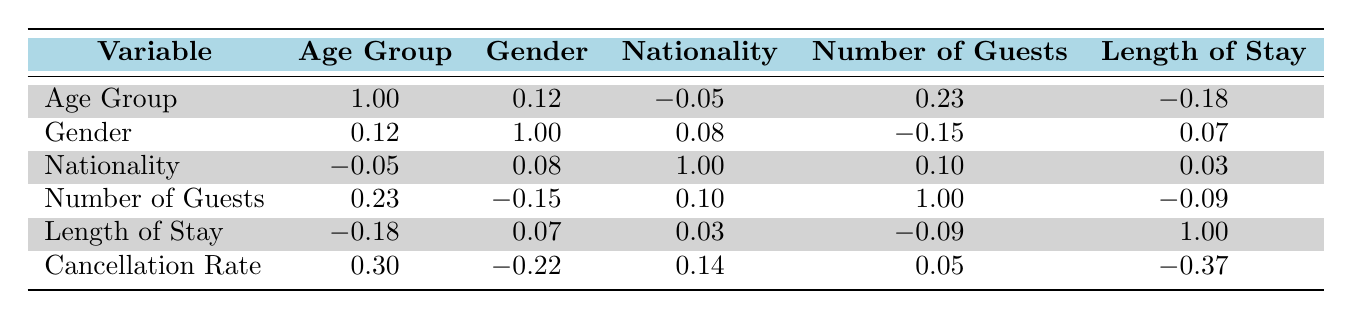What is the cancellation rate for female guests in the age group 55+? The table shows that for female guests in the age group 55+, the cancellation rate is listed as 0.20.
Answer: 0.20 How many guests are in the age group 25-34? There are two entries under the age group 25-34, one for a male guest with 1 guest and another for a female guest with 2 guests. By summing these values, 1 + 2 = 3 guests total.
Answer: 3 What is the correlation between the number of guests and the cancellation rate? Looking at the correlation table, the correlation coefficient between the number of guests and the cancellation rate is 0.05, which indicates a very weak positive correlation.
Answer: 0.05 Is the cancellation rate higher for female guests than for male guests? To answer this question, I compare the cancellation rates for each gender. Female guests have rates of 0.15 (age 18-24), 0.05 (age 35-44), and 0.20 (age 55+), giving an average of (0.15 + 0.05 + 0.20)/3 = 0.133. Male guests have rates of 0.08 (age 25-34), 0.12 (age 45-54), and 0.10 (age 18-24), giving (0.08 + 0.12 + 0.10)/3 = 0.10. Thus, female guests have a higher average cancellation rate.
Answer: Yes What is the average cancellation rate for guests in the age group 35-44? The cancellation rates for the 35-44 age group are 0.05 (female, British) and 0.13 (male, Indian). To find the average, I sum these rates and divide by the number of entries: (0.05 + 0.13) / 2 = 0.09.
Answer: 0.09 Is there a negative correlation between the length of stay and the cancellation rate? The correlation coefficient between the length of stay and the cancellation rate is -0.37, which indicates a moderate negative correlation. This means that as the length of stay increases, the cancellation rate tends to decrease.
Answer: Yes Which nationality has the highest cancellation rate? Examining each cancellation rate, the values are: Brazilian (0.15), American (0.08), British (0.05), German (0.12), Canadian (0.20), Australian (0.10), and Japanese (0.07). The Canadian nationality has the highest cancellation rate of 0.20.
Answer: Canadian How many guests in total are in the age group 45-54? There is one entry for the 45-54 age group, which indicates 2 male guests. Therefore, the total number of guests in this age group is 2.
Answer: 2 